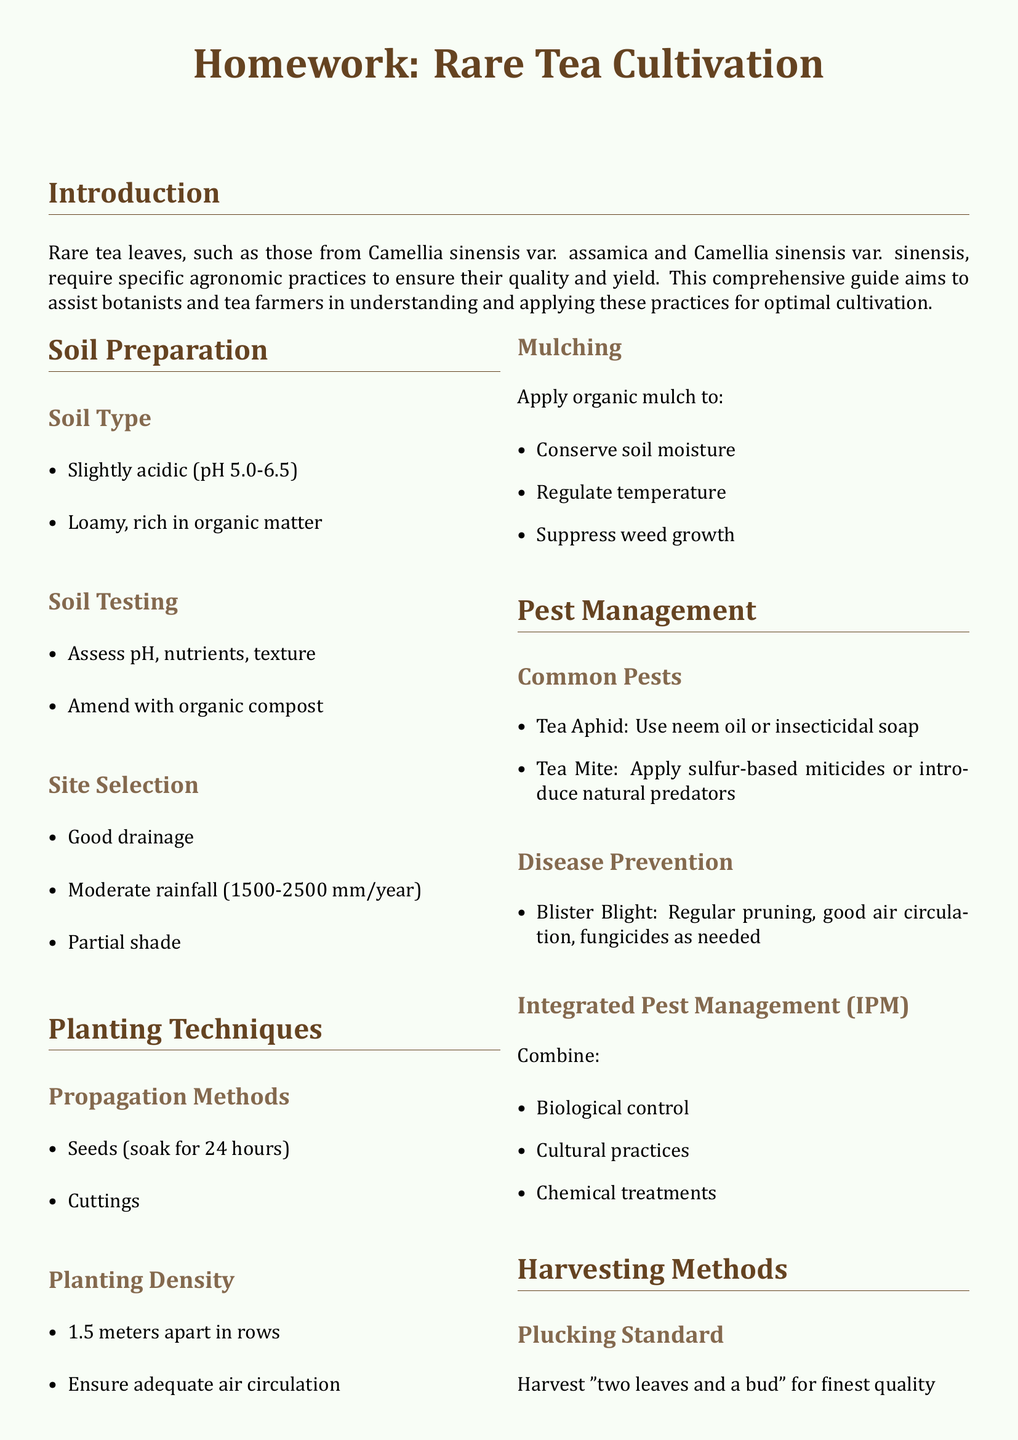What is the ideal soil pH for rare tea leaves? The document specifies that the ideal soil pH should be slightly acidic, ranging from 5.0 to 6.5.
Answer: 5.0-6.5 What should be applied to conserve soil moisture? The document states that organic mulch should be applied to conserve soil moisture and regulate temperature.
Answer: Organic mulch What is the harvesting standard mentioned for the finest quality tea? The document indicates that the harvesting standard for the finest quality tea is to pluck "two leaves and a bud."
Answer: Two leaves and a bud What is recommended to combat tea aphids? The document suggests using neem oil or insecticidal soap to combat tea aphids.
Answer: Neem oil or insecticidal soap How often should rare tea leaves be harvested during the growing season? According to the document, rare tea leaves should be harvested every 7-10 days during the growing season.
Answer: Every 7-10 days What type of pest management combines biological control, cultural practices, and chemical treatments? The document refers to this approach as Integrated Pest Management (IPM).
Answer: Integrated Pest Management (IPM) What is the recommended distance for planting tea plants? The document states that tea plants should be planted 1.5 meters apart in rows.
Answer: 1.5 meters apart What should be tested in the soil preparation process? The document mentions that soil testing should assess pH, nutrients, and texture.
Answer: pH, nutrients, texture What is a key practice to prevent blister blight? The document recommends regular pruning and ensuring good air circulation to prevent blister blight.
Answer: Regular pruning and good air circulation 